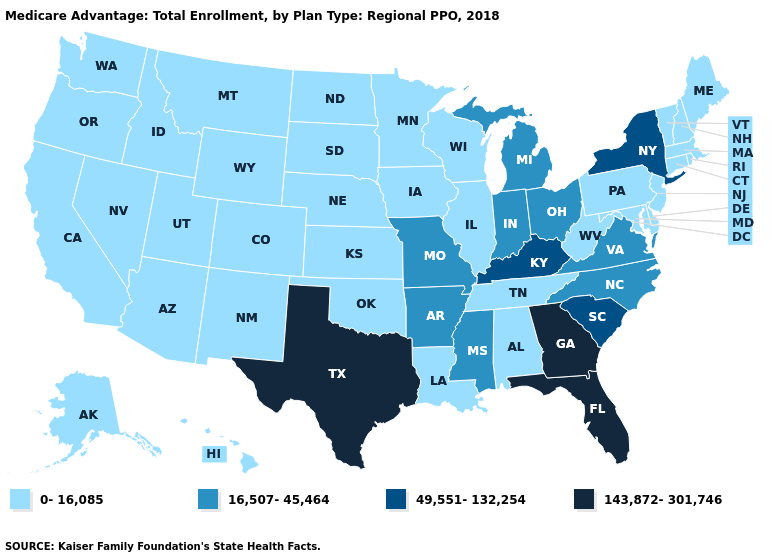Name the states that have a value in the range 143,872-301,746?
Give a very brief answer. Florida, Georgia, Texas. Name the states that have a value in the range 49,551-132,254?
Be succinct. Kentucky, New York, South Carolina. Among the states that border South Carolina , which have the lowest value?
Give a very brief answer. North Carolina. What is the value of Alaska?
Concise answer only. 0-16,085. What is the value of New Hampshire?
Keep it brief. 0-16,085. What is the highest value in states that border Oregon?
Give a very brief answer. 0-16,085. Which states have the lowest value in the USA?
Keep it brief. Alabama, Alaska, Arizona, California, Colorado, Connecticut, Delaware, Hawaii, Idaho, Illinois, Iowa, Kansas, Louisiana, Maine, Maryland, Massachusetts, Minnesota, Montana, Nebraska, Nevada, New Hampshire, New Jersey, New Mexico, North Dakota, Oklahoma, Oregon, Pennsylvania, Rhode Island, South Dakota, Tennessee, Utah, Vermont, Washington, West Virginia, Wisconsin, Wyoming. Does the first symbol in the legend represent the smallest category?
Concise answer only. Yes. Among the states that border Louisiana , does Mississippi have the highest value?
Concise answer only. No. What is the value of North Dakota?
Answer briefly. 0-16,085. Among the states that border New York , which have the lowest value?
Answer briefly. Connecticut, Massachusetts, New Jersey, Pennsylvania, Vermont. What is the highest value in the USA?
Short answer required. 143,872-301,746. Does the first symbol in the legend represent the smallest category?
Write a very short answer. Yes. 